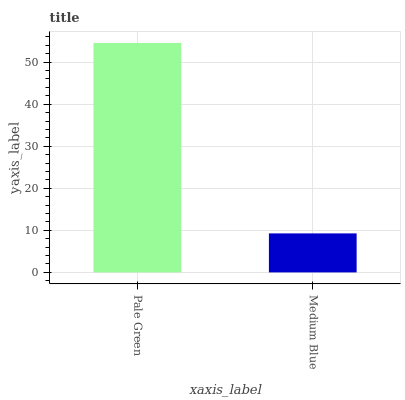Is Medium Blue the minimum?
Answer yes or no. Yes. Is Pale Green the maximum?
Answer yes or no. Yes. Is Medium Blue the maximum?
Answer yes or no. No. Is Pale Green greater than Medium Blue?
Answer yes or no. Yes. Is Medium Blue less than Pale Green?
Answer yes or no. Yes. Is Medium Blue greater than Pale Green?
Answer yes or no. No. Is Pale Green less than Medium Blue?
Answer yes or no. No. Is Pale Green the high median?
Answer yes or no. Yes. Is Medium Blue the low median?
Answer yes or no. Yes. Is Medium Blue the high median?
Answer yes or no. No. Is Pale Green the low median?
Answer yes or no. No. 